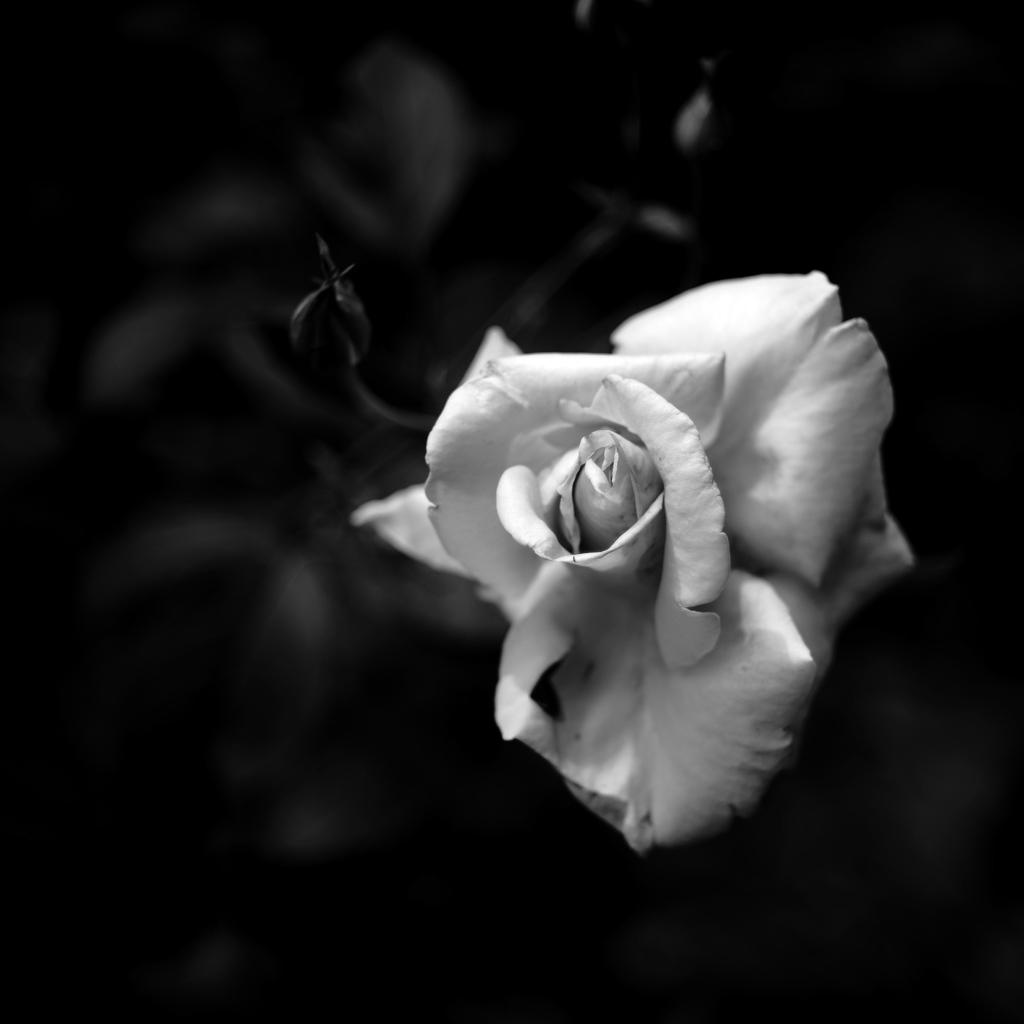What is the main subject of the image? There is a flower in the image. What is the color scheme of the image? The image is black and white. Where is the flower located in the image? The flower is in the foreground of the image. What type of horn can be seen on the flower in the image? There is no horn present on the flower in the image. What is the opinion of the flower in the image? The image does not convey an opinion about the flower; it simply depicts the flower. 